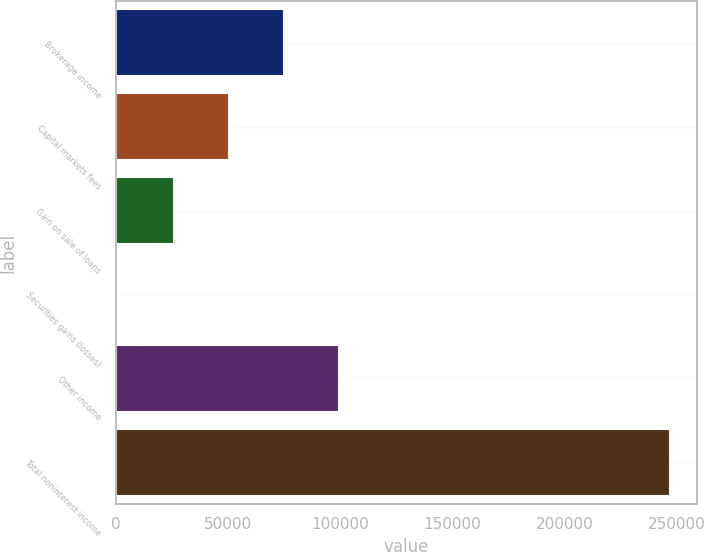Convert chart to OTSL. <chart><loc_0><loc_0><loc_500><loc_500><bar_chart><fcel>Brokerage income<fcel>Capital markets fees<fcel>Gain on sale of loans<fcel>Securities gains (losses)<fcel>Other income<fcel>Total noninterest income<nl><fcel>74855.7<fcel>50316.8<fcel>25777.9<fcel>1239<fcel>99394.6<fcel>246628<nl></chart> 